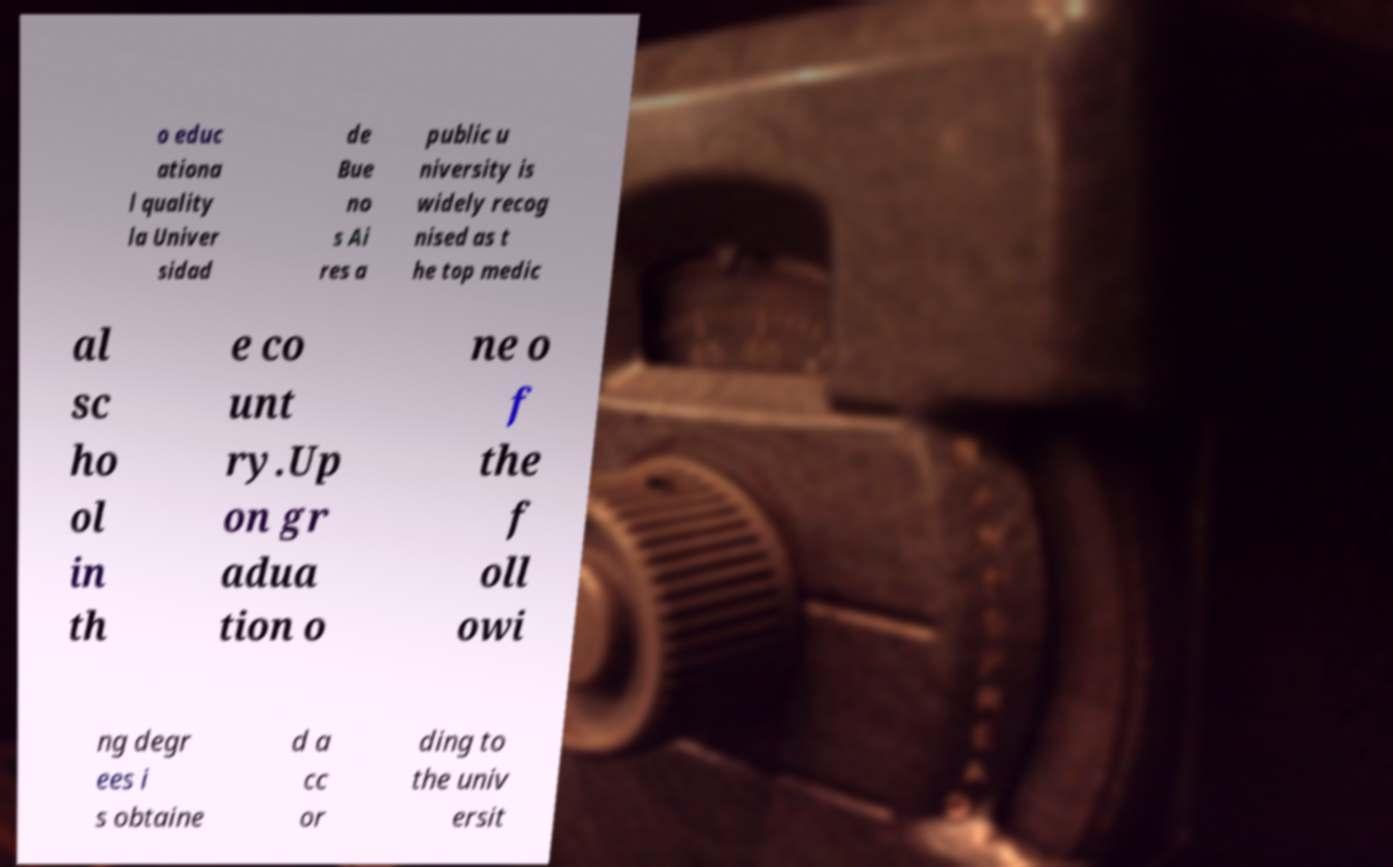Can you read and provide the text displayed in the image?This photo seems to have some interesting text. Can you extract and type it out for me? o educ ationa l quality la Univer sidad de Bue no s Ai res a public u niversity is widely recog nised as t he top medic al sc ho ol in th e co unt ry.Up on gr adua tion o ne o f the f oll owi ng degr ees i s obtaine d a cc or ding to the univ ersit 